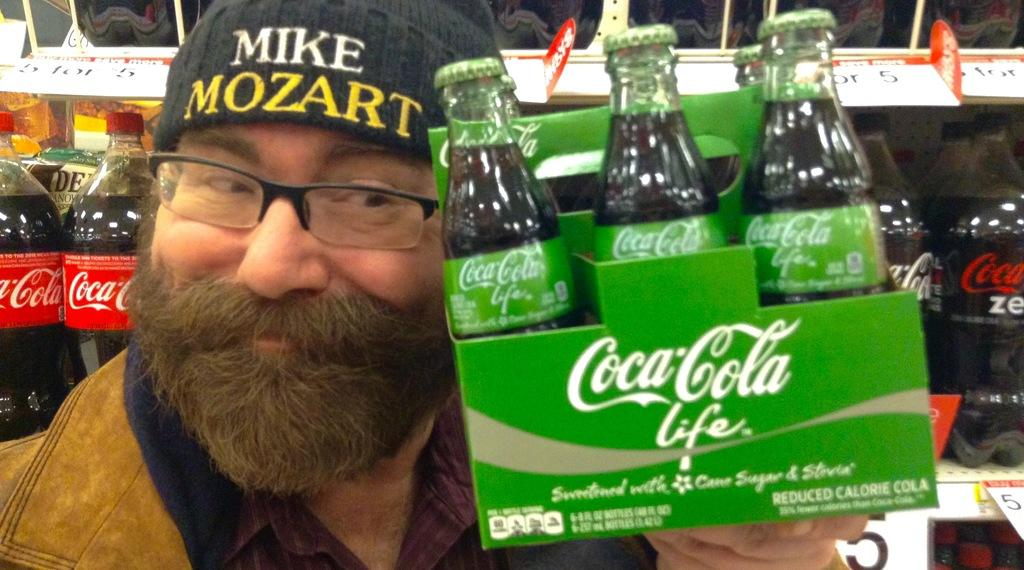Who is present in the image? There is a man in the image. What is the man holding in the image? The man is holding a bunch of Coca-Cola bottles. Can you describe the man's attire in the image? The man is wearing a cap and spectacles. What can be seen in the background of the image? There are bottles placed in a rack in the background of the image. What type of tin is the man using to perform the operation in the image? There is no operation or tin present in the image. 